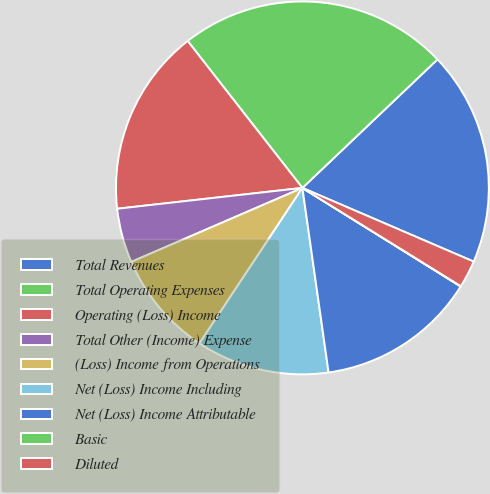Convert chart. <chart><loc_0><loc_0><loc_500><loc_500><pie_chart><fcel>Total Revenues<fcel>Total Operating Expenses<fcel>Operating (Loss) Income<fcel>Total Other (Income) Expense<fcel>(Loss) Income from Operations<fcel>Net (Loss) Income Including<fcel>Net (Loss) Income Attributable<fcel>Basic<fcel>Diluted<nl><fcel>18.57%<fcel>23.45%<fcel>16.23%<fcel>4.71%<fcel>9.2%<fcel>11.55%<fcel>13.89%<fcel>0.03%<fcel>2.37%<nl></chart> 